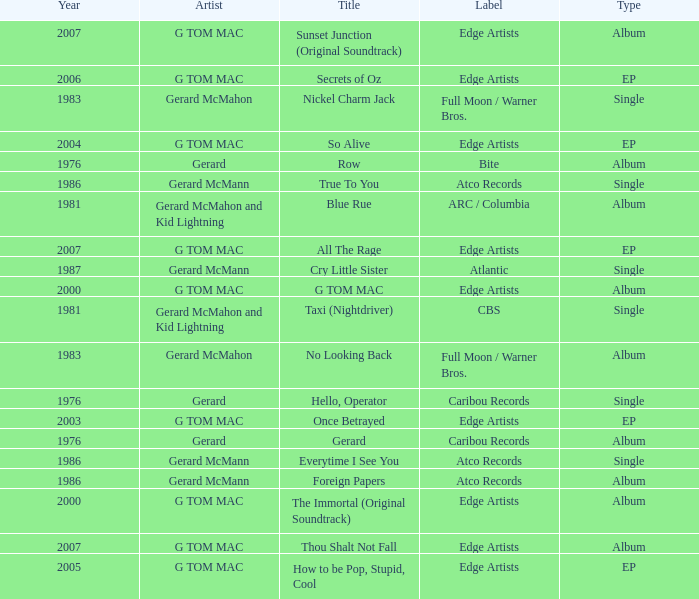Which Title has a Type of ep and a Year larger than 2003? So Alive, How to be Pop, Stupid, Cool, Secrets of Oz, All The Rage. 